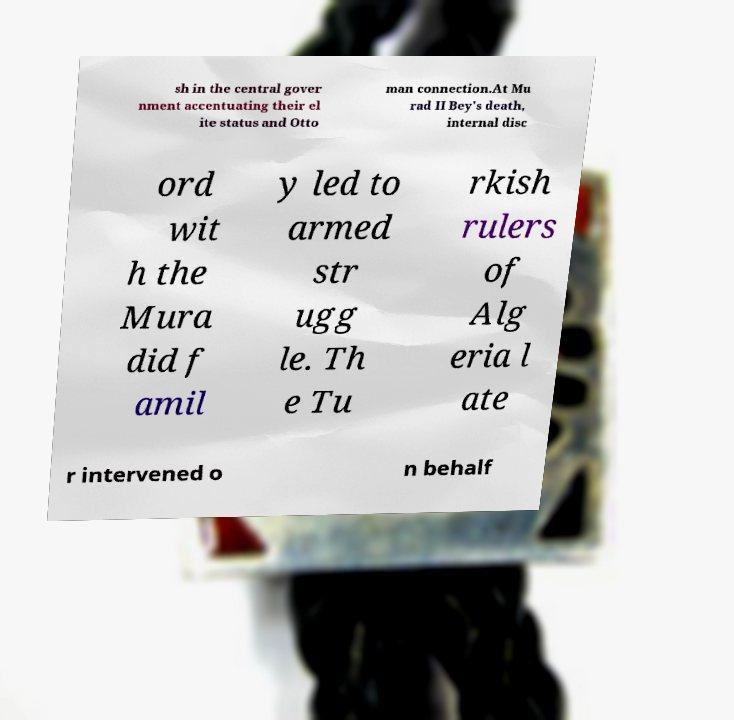I need the written content from this picture converted into text. Can you do that? sh in the central gover nment accentuating their el ite status and Otto man connection.At Mu rad II Bey's death, internal disc ord wit h the Mura did f amil y led to armed str ugg le. Th e Tu rkish rulers of Alg eria l ate r intervened o n behalf 